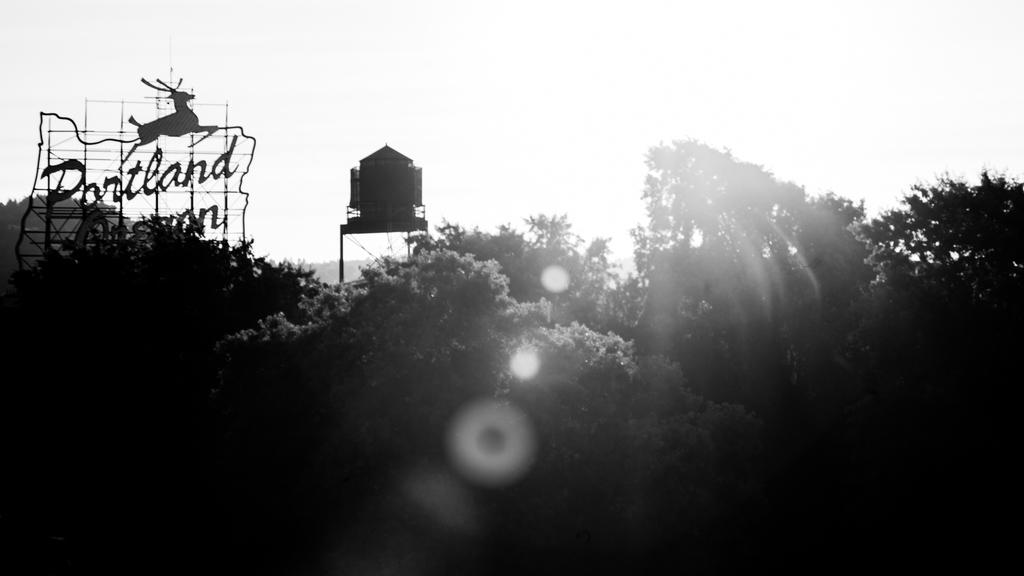What type of natural elements can be seen in the image? There are trees in the image. What man-made structure is visible in the image? There is a water tank in the image. What object is present with a writing surface? There is a board in the image. What is depicted on the board? There is an animal image on the board. What is written on the board? Something is written on the board. How is the image presented in terms of color? The image is in black and white. What type of twist can be seen in the image? There is no twist present in the image. How many women are visible in the image? There are no women present in the image. 